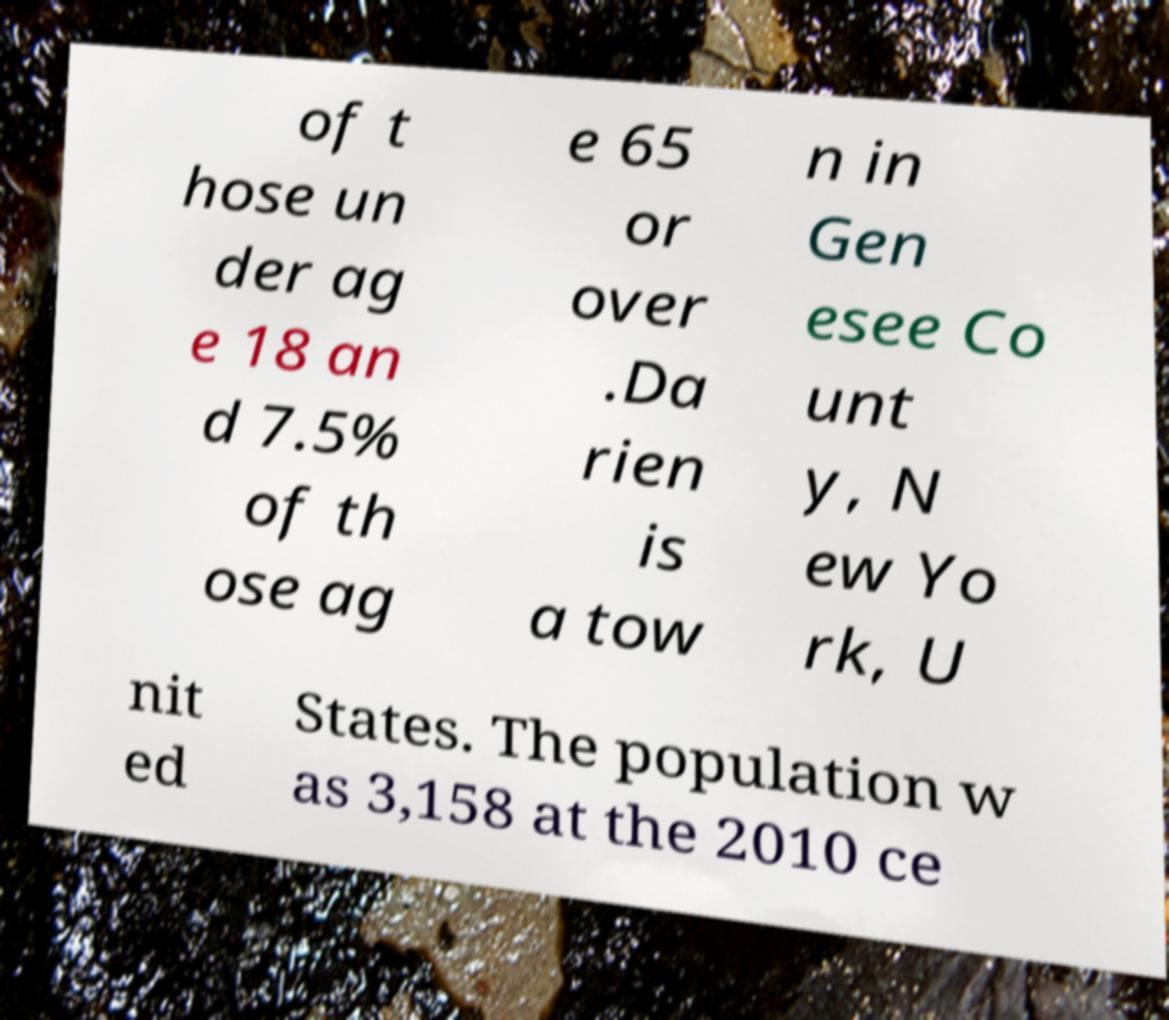Can you read and provide the text displayed in the image?This photo seems to have some interesting text. Can you extract and type it out for me? of t hose un der ag e 18 an d 7.5% of th ose ag e 65 or over .Da rien is a tow n in Gen esee Co unt y, N ew Yo rk, U nit ed States. The population w as 3,158 at the 2010 ce 